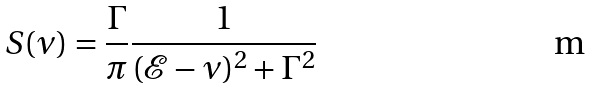Convert formula to latex. <formula><loc_0><loc_0><loc_500><loc_500>S ( \nu ) = \frac { \Gamma } { \pi } \frac { 1 } { ( \mathcal { E } - \nu ) ^ { 2 } + \Gamma ^ { 2 } }</formula> 